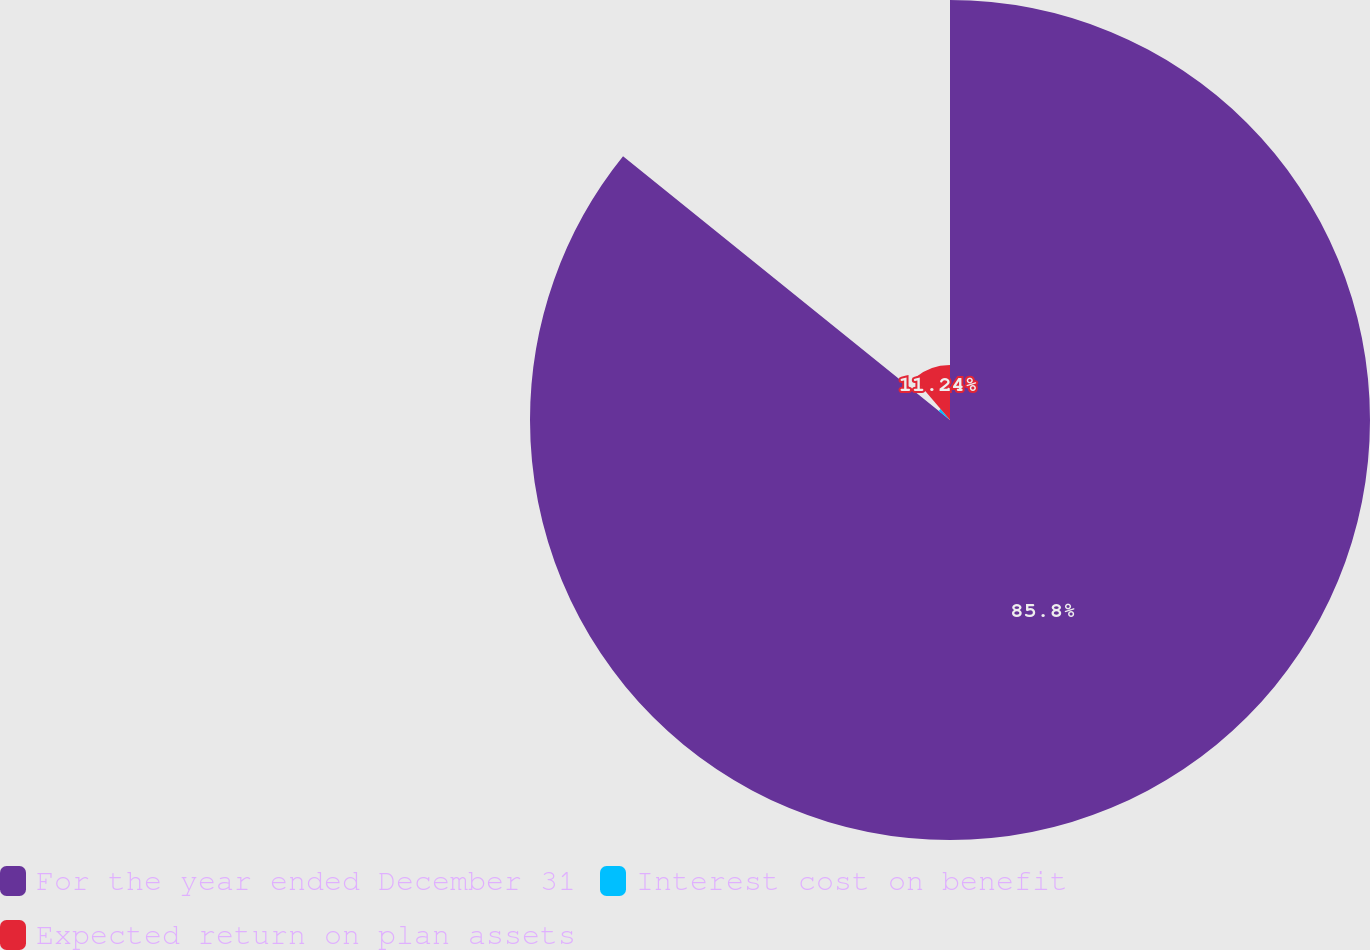Convert chart. <chart><loc_0><loc_0><loc_500><loc_500><pie_chart><fcel>For the year ended December 31<fcel>Interest cost on benefit<fcel>Expected return on plan assets<nl><fcel>85.8%<fcel>2.96%<fcel>11.24%<nl></chart> 